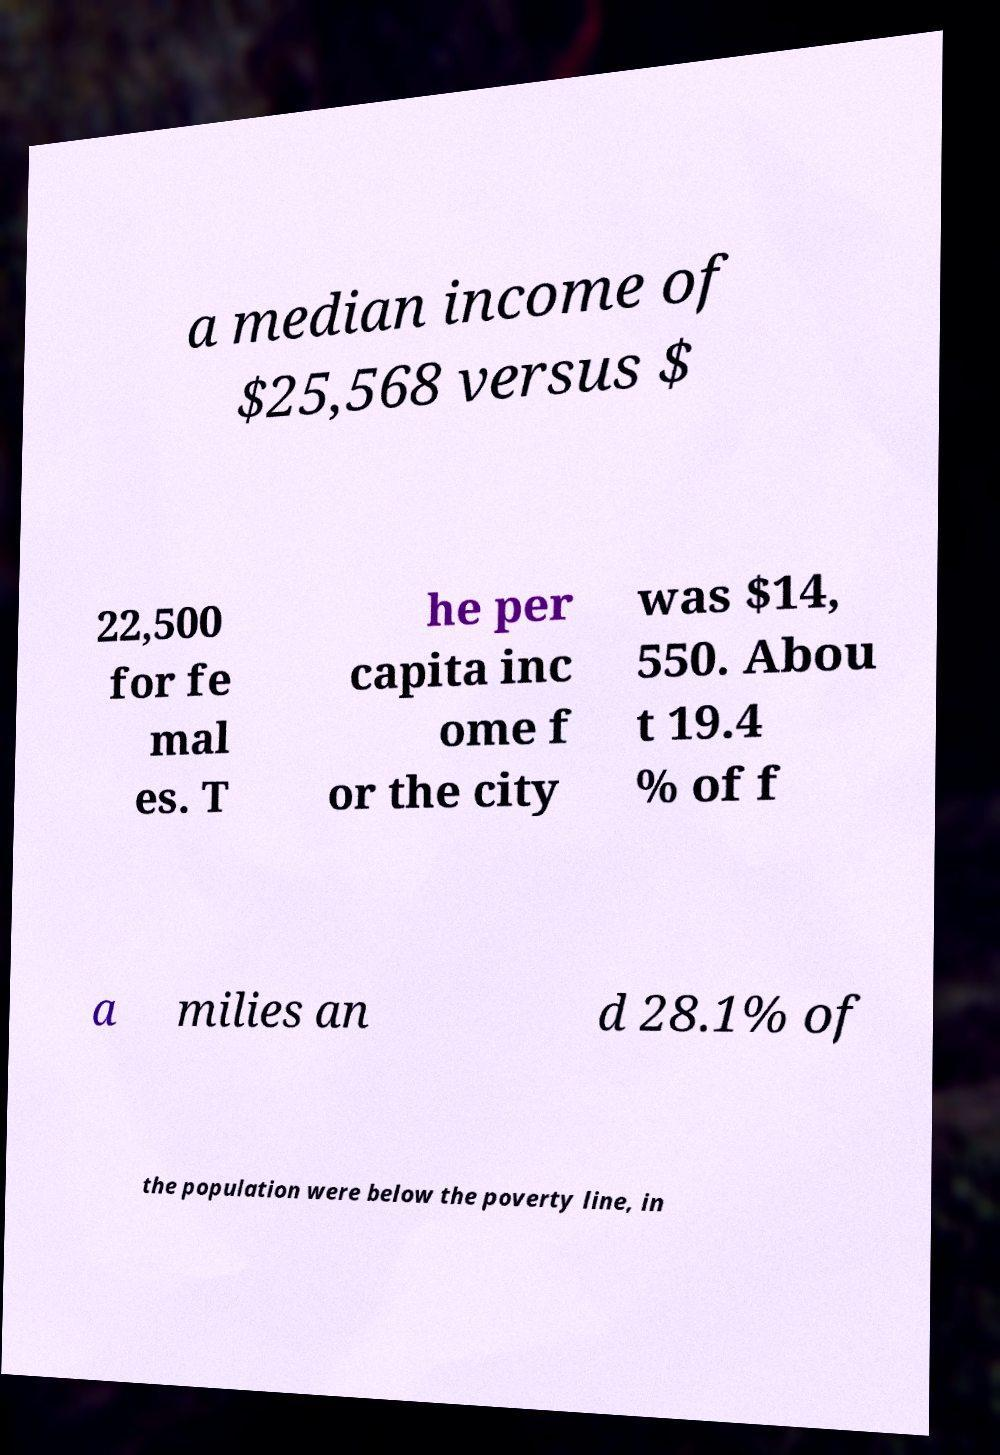There's text embedded in this image that I need extracted. Can you transcribe it verbatim? a median income of $25,568 versus $ 22,500 for fe mal es. T he per capita inc ome f or the city was $14, 550. Abou t 19.4 % of f a milies an d 28.1% of the population were below the poverty line, in 